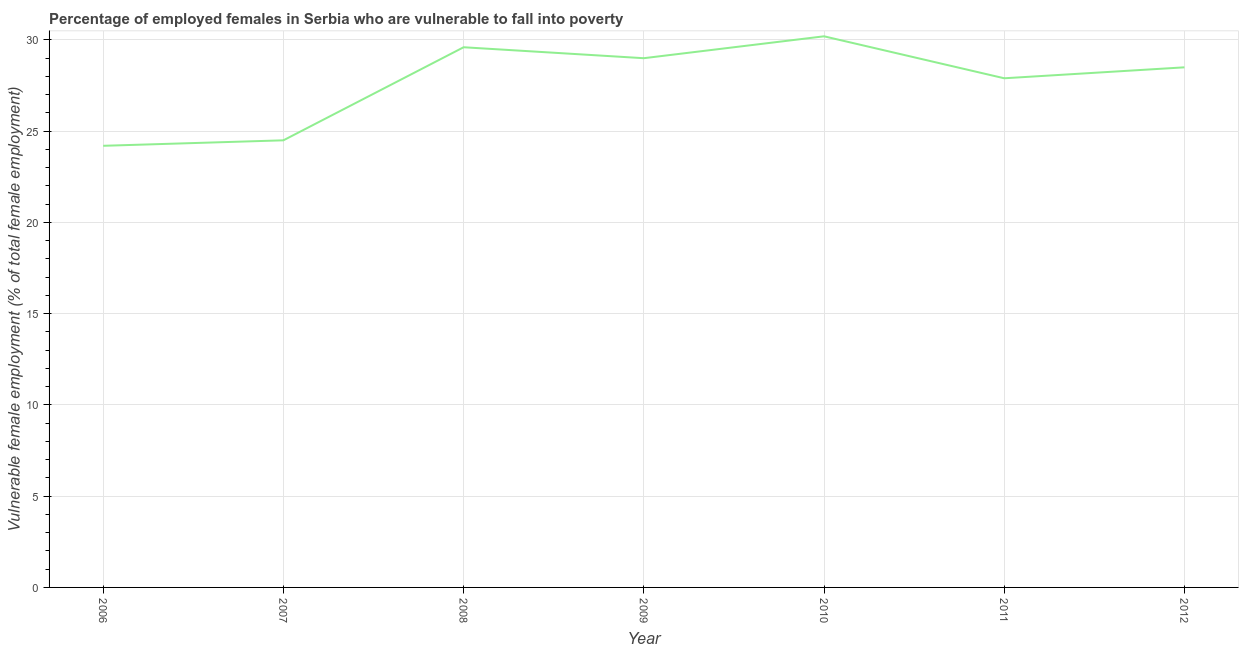Across all years, what is the maximum percentage of employed females who are vulnerable to fall into poverty?
Offer a terse response. 30.2. Across all years, what is the minimum percentage of employed females who are vulnerable to fall into poverty?
Give a very brief answer. 24.2. In which year was the percentage of employed females who are vulnerable to fall into poverty maximum?
Offer a terse response. 2010. In which year was the percentage of employed females who are vulnerable to fall into poverty minimum?
Keep it short and to the point. 2006. What is the sum of the percentage of employed females who are vulnerable to fall into poverty?
Your response must be concise. 193.9. What is the difference between the percentage of employed females who are vulnerable to fall into poverty in 2006 and 2008?
Offer a terse response. -5.4. What is the average percentage of employed females who are vulnerable to fall into poverty per year?
Provide a succinct answer. 27.7. In how many years, is the percentage of employed females who are vulnerable to fall into poverty greater than 28 %?
Your answer should be compact. 4. What is the ratio of the percentage of employed females who are vulnerable to fall into poverty in 2009 to that in 2011?
Your answer should be compact. 1.04. What is the difference between the highest and the second highest percentage of employed females who are vulnerable to fall into poverty?
Provide a succinct answer. 0.6. Is the sum of the percentage of employed females who are vulnerable to fall into poverty in 2010 and 2012 greater than the maximum percentage of employed females who are vulnerable to fall into poverty across all years?
Keep it short and to the point. Yes. Are the values on the major ticks of Y-axis written in scientific E-notation?
Offer a terse response. No. What is the title of the graph?
Ensure brevity in your answer.  Percentage of employed females in Serbia who are vulnerable to fall into poverty. What is the label or title of the Y-axis?
Offer a very short reply. Vulnerable female employment (% of total female employment). What is the Vulnerable female employment (% of total female employment) in 2006?
Ensure brevity in your answer.  24.2. What is the Vulnerable female employment (% of total female employment) in 2008?
Your answer should be very brief. 29.6. What is the Vulnerable female employment (% of total female employment) of 2010?
Give a very brief answer. 30.2. What is the Vulnerable female employment (% of total female employment) of 2011?
Offer a very short reply. 27.9. What is the difference between the Vulnerable female employment (% of total female employment) in 2006 and 2010?
Keep it short and to the point. -6. What is the difference between the Vulnerable female employment (% of total female employment) in 2006 and 2012?
Your answer should be very brief. -4.3. What is the difference between the Vulnerable female employment (% of total female employment) in 2007 and 2008?
Give a very brief answer. -5.1. What is the difference between the Vulnerable female employment (% of total female employment) in 2008 and 2010?
Offer a very short reply. -0.6. What is the difference between the Vulnerable female employment (% of total female employment) in 2008 and 2011?
Provide a short and direct response. 1.7. What is the difference between the Vulnerable female employment (% of total female employment) in 2009 and 2010?
Your answer should be very brief. -1.2. What is the ratio of the Vulnerable female employment (% of total female employment) in 2006 to that in 2008?
Your answer should be very brief. 0.82. What is the ratio of the Vulnerable female employment (% of total female employment) in 2006 to that in 2009?
Your answer should be compact. 0.83. What is the ratio of the Vulnerable female employment (% of total female employment) in 2006 to that in 2010?
Your answer should be compact. 0.8. What is the ratio of the Vulnerable female employment (% of total female employment) in 2006 to that in 2011?
Your response must be concise. 0.87. What is the ratio of the Vulnerable female employment (% of total female employment) in 2006 to that in 2012?
Provide a succinct answer. 0.85. What is the ratio of the Vulnerable female employment (% of total female employment) in 2007 to that in 2008?
Your answer should be compact. 0.83. What is the ratio of the Vulnerable female employment (% of total female employment) in 2007 to that in 2009?
Ensure brevity in your answer.  0.84. What is the ratio of the Vulnerable female employment (% of total female employment) in 2007 to that in 2010?
Give a very brief answer. 0.81. What is the ratio of the Vulnerable female employment (% of total female employment) in 2007 to that in 2011?
Ensure brevity in your answer.  0.88. What is the ratio of the Vulnerable female employment (% of total female employment) in 2007 to that in 2012?
Offer a very short reply. 0.86. What is the ratio of the Vulnerable female employment (% of total female employment) in 2008 to that in 2011?
Your response must be concise. 1.06. What is the ratio of the Vulnerable female employment (% of total female employment) in 2008 to that in 2012?
Provide a short and direct response. 1.04. What is the ratio of the Vulnerable female employment (% of total female employment) in 2009 to that in 2010?
Keep it short and to the point. 0.96. What is the ratio of the Vulnerable female employment (% of total female employment) in 2009 to that in 2011?
Provide a short and direct response. 1.04. What is the ratio of the Vulnerable female employment (% of total female employment) in 2010 to that in 2011?
Provide a succinct answer. 1.08. What is the ratio of the Vulnerable female employment (% of total female employment) in 2010 to that in 2012?
Keep it short and to the point. 1.06. 